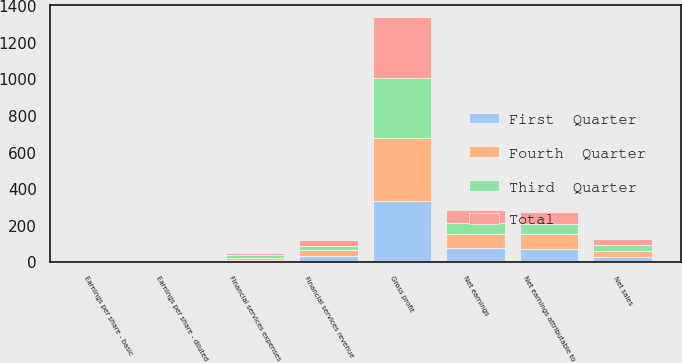<chart> <loc_0><loc_0><loc_500><loc_500><stacked_bar_chart><ecel><fcel>Net sales<fcel>Gross profit<fcel>Financial services revenue<fcel>Financial services expenses<fcel>Net earnings<fcel>Net earnings attributable to<fcel>Earnings per share - basic<fcel>Earnings per share - diluted<nl><fcel>Third  Quarter<fcel>31.5<fcel>330.6<fcel>25.8<fcel>13.3<fcel>58<fcel>56.2<fcel>0.97<fcel>0.96<nl><fcel>Fourth  Quarter<fcel>31.5<fcel>342.2<fcel>30.3<fcel>12.8<fcel>79.9<fcel>78<fcel>1.34<fcel>1.33<nl><fcel>Total<fcel>31.5<fcel>329.3<fcel>32.7<fcel>11.9<fcel>69.8<fcel>67.8<fcel>1.16<fcel>1.16<nl><fcel>First  Quarter<fcel>31.5<fcel>335.8<fcel>35.5<fcel>13.4<fcel>76.1<fcel>74.3<fcel>1.28<fcel>1.27<nl></chart> 